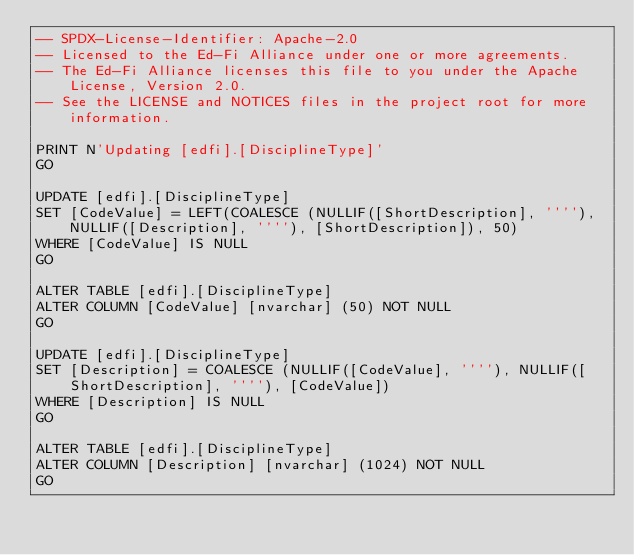Convert code to text. <code><loc_0><loc_0><loc_500><loc_500><_SQL_>-- SPDX-License-Identifier: Apache-2.0
-- Licensed to the Ed-Fi Alliance under one or more agreements.
-- The Ed-Fi Alliance licenses this file to you under the Apache License, Version 2.0.
-- See the LICENSE and NOTICES files in the project root for more information.

PRINT N'Updating [edfi].[DisciplineType]'
GO

UPDATE [edfi].[DisciplineType]
SET [CodeValue] = LEFT(COALESCE (NULLIF([ShortDescription], ''''), NULLIF([Description], ''''), [ShortDescription]), 50)
WHERE [CodeValue] IS NULL
GO

ALTER TABLE [edfi].[DisciplineType]
ALTER COLUMN [CodeValue] [nvarchar] (50) NOT NULL
GO

UPDATE [edfi].[DisciplineType]
SET [Description] = COALESCE (NULLIF([CodeValue], ''''), NULLIF([ShortDescription], ''''), [CodeValue])
WHERE [Description] IS NULL
GO

ALTER TABLE [edfi].[DisciplineType]
ALTER COLUMN [Description] [nvarchar] (1024) NOT NULL
GO
</code> 